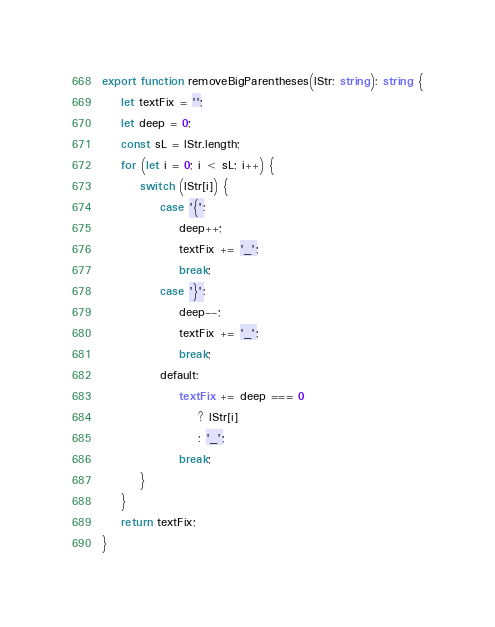Convert code to text. <code><loc_0><loc_0><loc_500><loc_500><_TypeScript_>export function removeBigParentheses(lStr: string): string {
    let textFix = '';
    let deep = 0;
    const sL = lStr.length;
    for (let i = 0; i < sL; i++) {
        switch (lStr[i]) {
            case '{':
                deep++;
                textFix += '_';
                break;
            case '}':
                deep--;
                textFix += '_';
                break;
            default:
                textFix += deep === 0
                    ? lStr[i]
                    : '_';
                break;
        }
    }
    return textFix;
}
</code> 